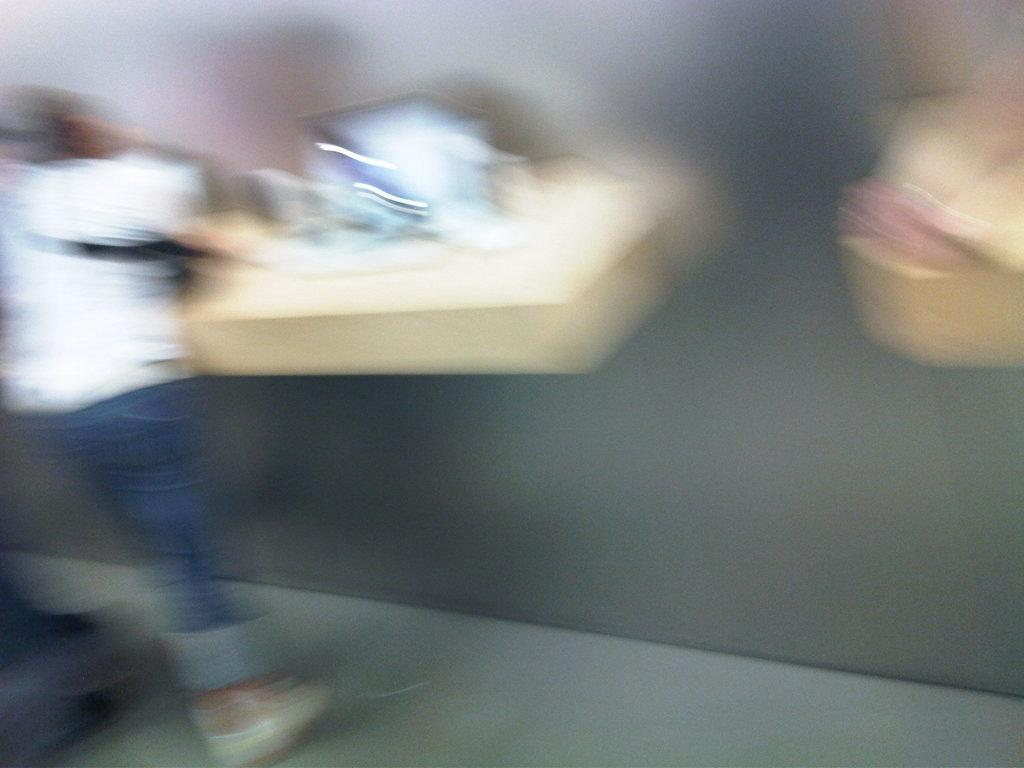What is the overall quality of the image? The image is blurred. Can you describe the person on the left side of the image? There is a person on the left side of the image, but their appearance cannot be clearly discerned due to the blurriness. What can be seen on the wall in the image? There are objects on the wall in the image, but their details are also obscured by the blurriness. What is the person on the left side of the image talking about in the image? It is impossible to determine what the person is talking about, as the image is blurred and their appearance cannot be clearly discerned. 